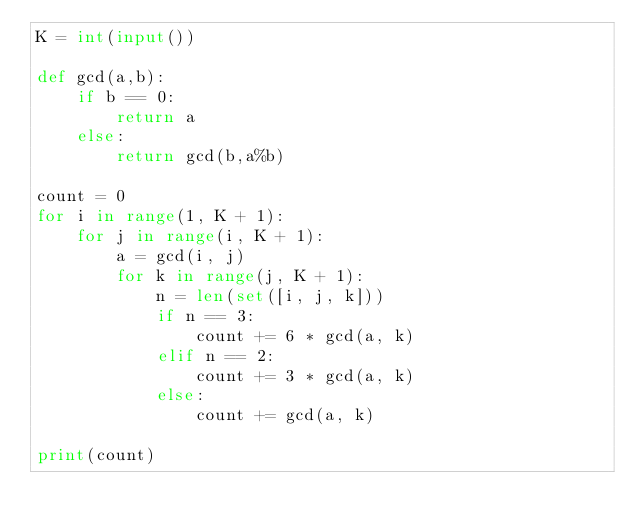Convert code to text. <code><loc_0><loc_0><loc_500><loc_500><_Python_>K = int(input())

def gcd(a,b):
    if b == 0:
        return a
    else:
        return gcd(b,a%b)

count = 0
for i in range(1, K + 1):
    for j in range(i, K + 1):
        a = gcd(i, j)
        for k in range(j, K + 1):
            n = len(set([i, j, k]))
            if n == 3:
                count += 6 * gcd(a, k)
            elif n == 2:
                count += 3 * gcd(a, k)
            else:
                count += gcd(a, k)
            
print(count)</code> 